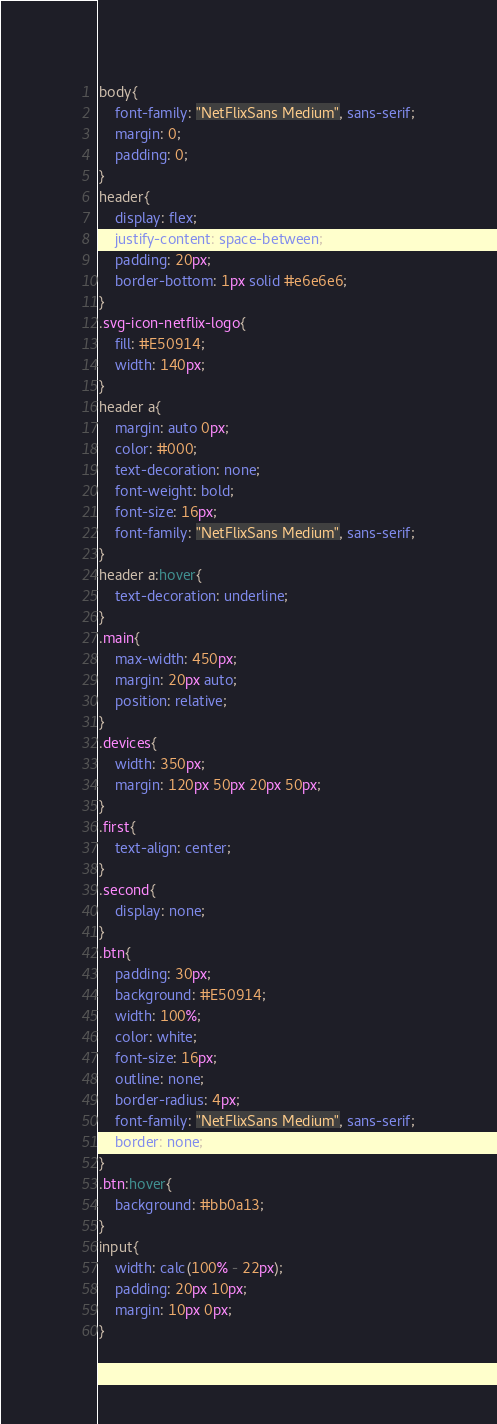Convert code to text. <code><loc_0><loc_0><loc_500><loc_500><_CSS_>body{
    font-family: "NetFlixSans Medium", sans-serif;
    margin: 0;
    padding: 0;
}
header{
    display: flex;
    justify-content: space-between;
    padding: 20px;
    border-bottom: 1px solid #e6e6e6;
}
.svg-icon-netflix-logo{
    fill: #E50914;
    width: 140px;
}
header a{
    margin: auto 0px;
    color: #000;
    text-decoration: none;
    font-weight: bold;
    font-size: 16px;
    font-family: "NetFlixSans Medium", sans-serif;
}
header a:hover{
    text-decoration: underline;
}
.main{
    max-width: 450px;
    margin: 20px auto;
    position: relative;
}
.devices{
    width: 350px;
    margin: 120px 50px 20px 50px;
}
.first{
    text-align: center;
}
.second{
    display: none;
}
.btn{
    padding: 30px;
    background: #E50914;
    width: 100%;
    color: white;
    font-size: 16px;
    outline: none;
    border-radius: 4px;
    font-family: "NetFlixSans Medium", sans-serif;
    border: none;
}
.btn:hover{
    background: #bb0a13;
}
input{
    width: calc(100% - 22px);
    padding: 20px 10px;
    margin: 10px 0px;
}</code> 